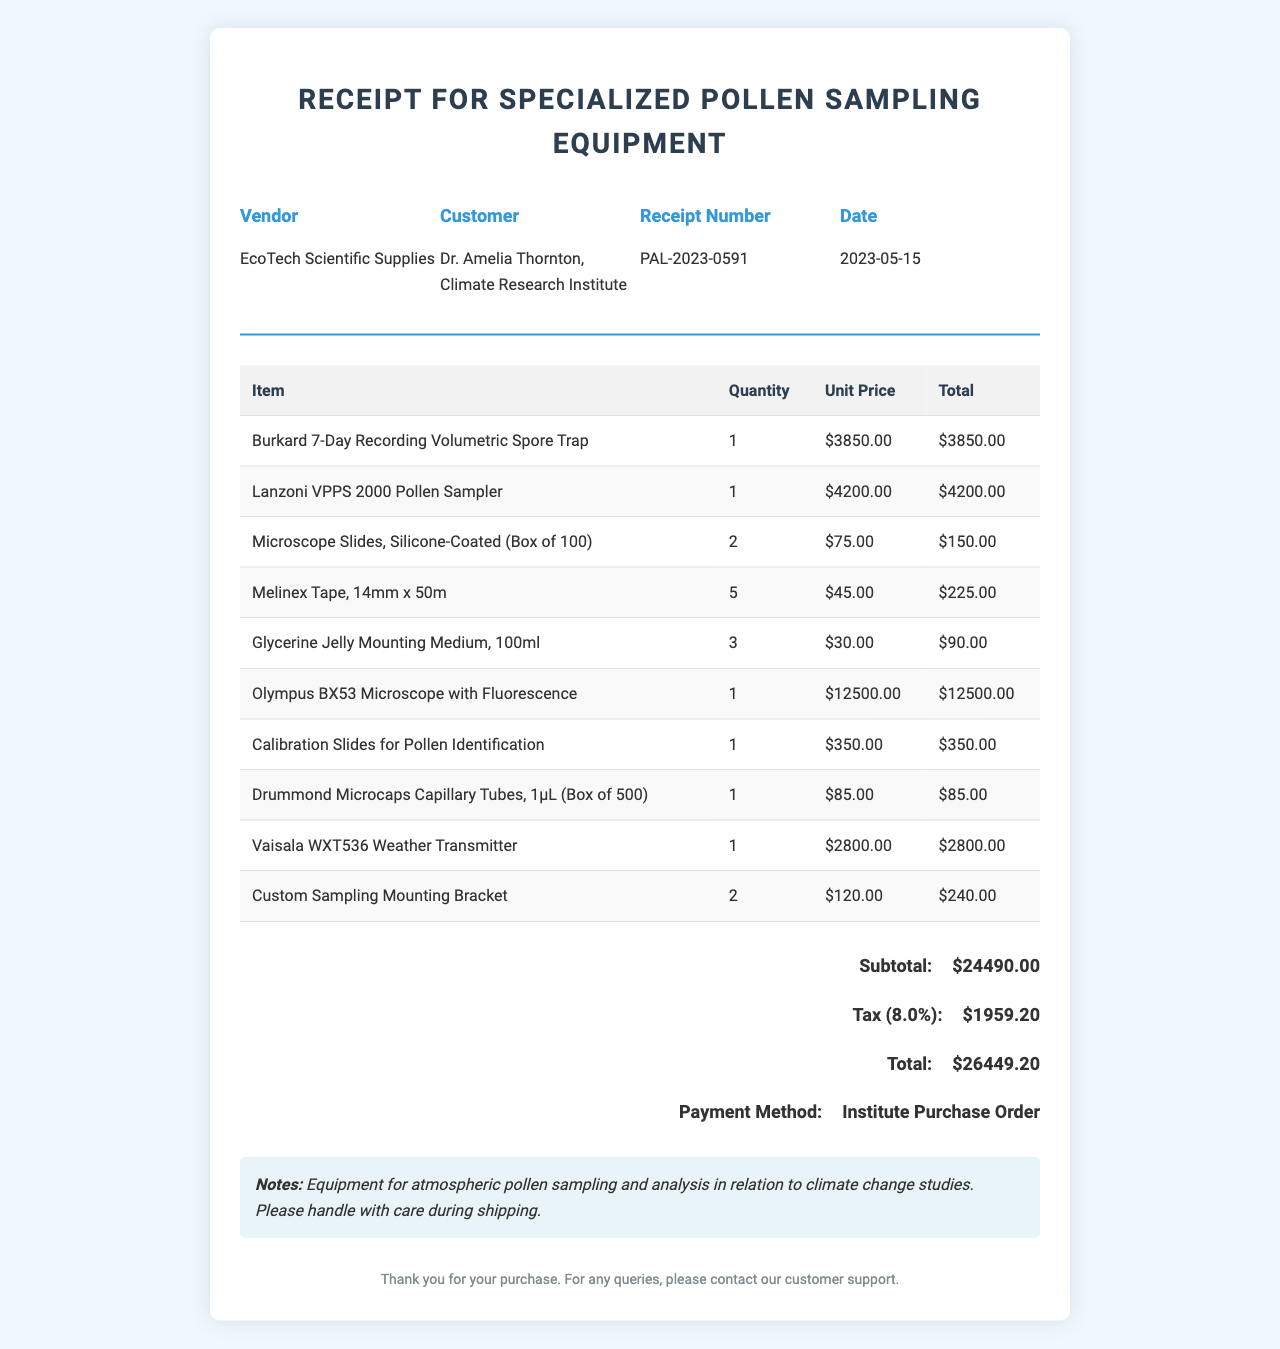What is the receipt number? The receipt number is a unique identifier for the transaction, which is displayed prominently in the document.
Answer: PAL-2023-0591 Who is the customer? The customer's name is listed in the receipt, indicating who made the purchase.
Answer: Dr. Amelia Thornton, Climate Research Institute What is the total amount due? The total amount due is the final charge after including all items, taxes, and fees on the receipt.
Answer: $26,449.20 How many Microscope Slides were purchased? The quantity of Microscope Slides is provided in the itemized list, showing how many were acquired.
Answer: 2 What is the unit price of the Vaisala WXT536 Weather Transmitter? The unit price is the individual cost of the Vaisala WXT536 Weather Transmitter in the receipt.
Answer: $2,800.00 What is the tax rate on the receipt? The tax rate is indicated as a percentage that applies to the subtotal for this transaction.
Answer: 8% Which item is the most expensive? The most expensive item listed on the receipt indicates which product cost the most for this purchase.
Answer: Olympus BX53 Microscope with Fluorescence How many Custom Sampling Mounting Brackets were purchased? The quantity of Custom Sampling Mounting Brackets is provided, helping understand the number of this specific item bought.
Answer: 2 What payment method was used for this purchase? The payment method details how the transaction was settled, which is noted at the bottom of the receipt.
Answer: Institute Purchase Order 